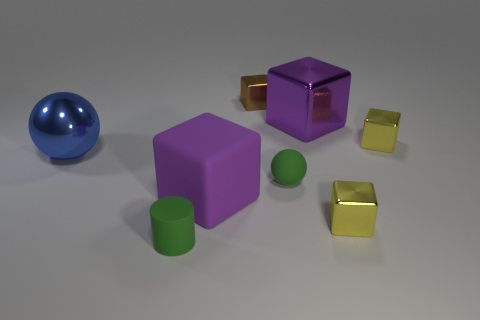Is there anything else that is the same size as the brown metallic thing?
Offer a very short reply. Yes. Are there more small cylinders to the left of the large metal ball than large blue things that are left of the big metallic cube?
Make the answer very short. No. There is a purple thing that is made of the same material as the small green ball; what shape is it?
Give a very brief answer. Cube. Is the number of green matte objects left of the large blue object greater than the number of blue things?
Your answer should be compact. No. What number of cylinders have the same color as the matte sphere?
Offer a very short reply. 1. How many other objects are there of the same color as the big rubber block?
Keep it short and to the point. 1. Are there more brown metal things than large green shiny balls?
Your answer should be compact. Yes. What is the material of the brown object?
Offer a very short reply. Metal. There is a yellow metallic thing that is behind the green matte sphere; is its size the same as the green matte cylinder?
Offer a terse response. Yes. What is the size of the green matte object that is right of the small matte cylinder?
Offer a very short reply. Small. 